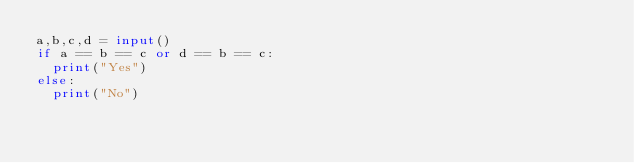<code> <loc_0><loc_0><loc_500><loc_500><_Python_>a,b,c,d = input()
if a == b == c or d == b == c:
  print("Yes")
else:
  print("No")
</code> 